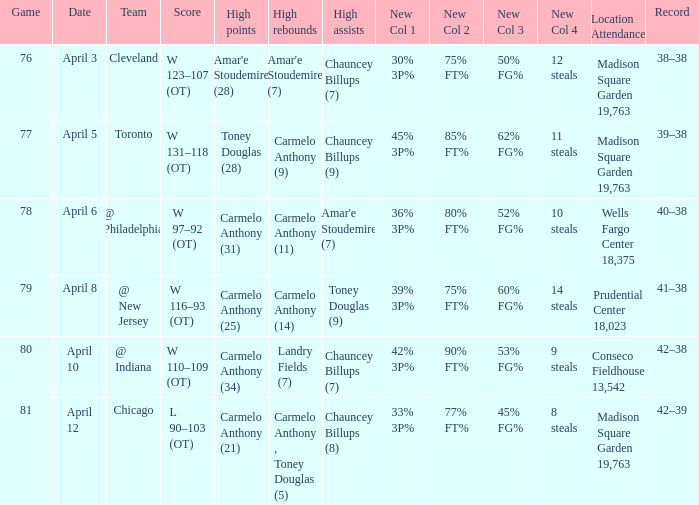Name the location attendance april 5 Madison Square Garden 19,763. 